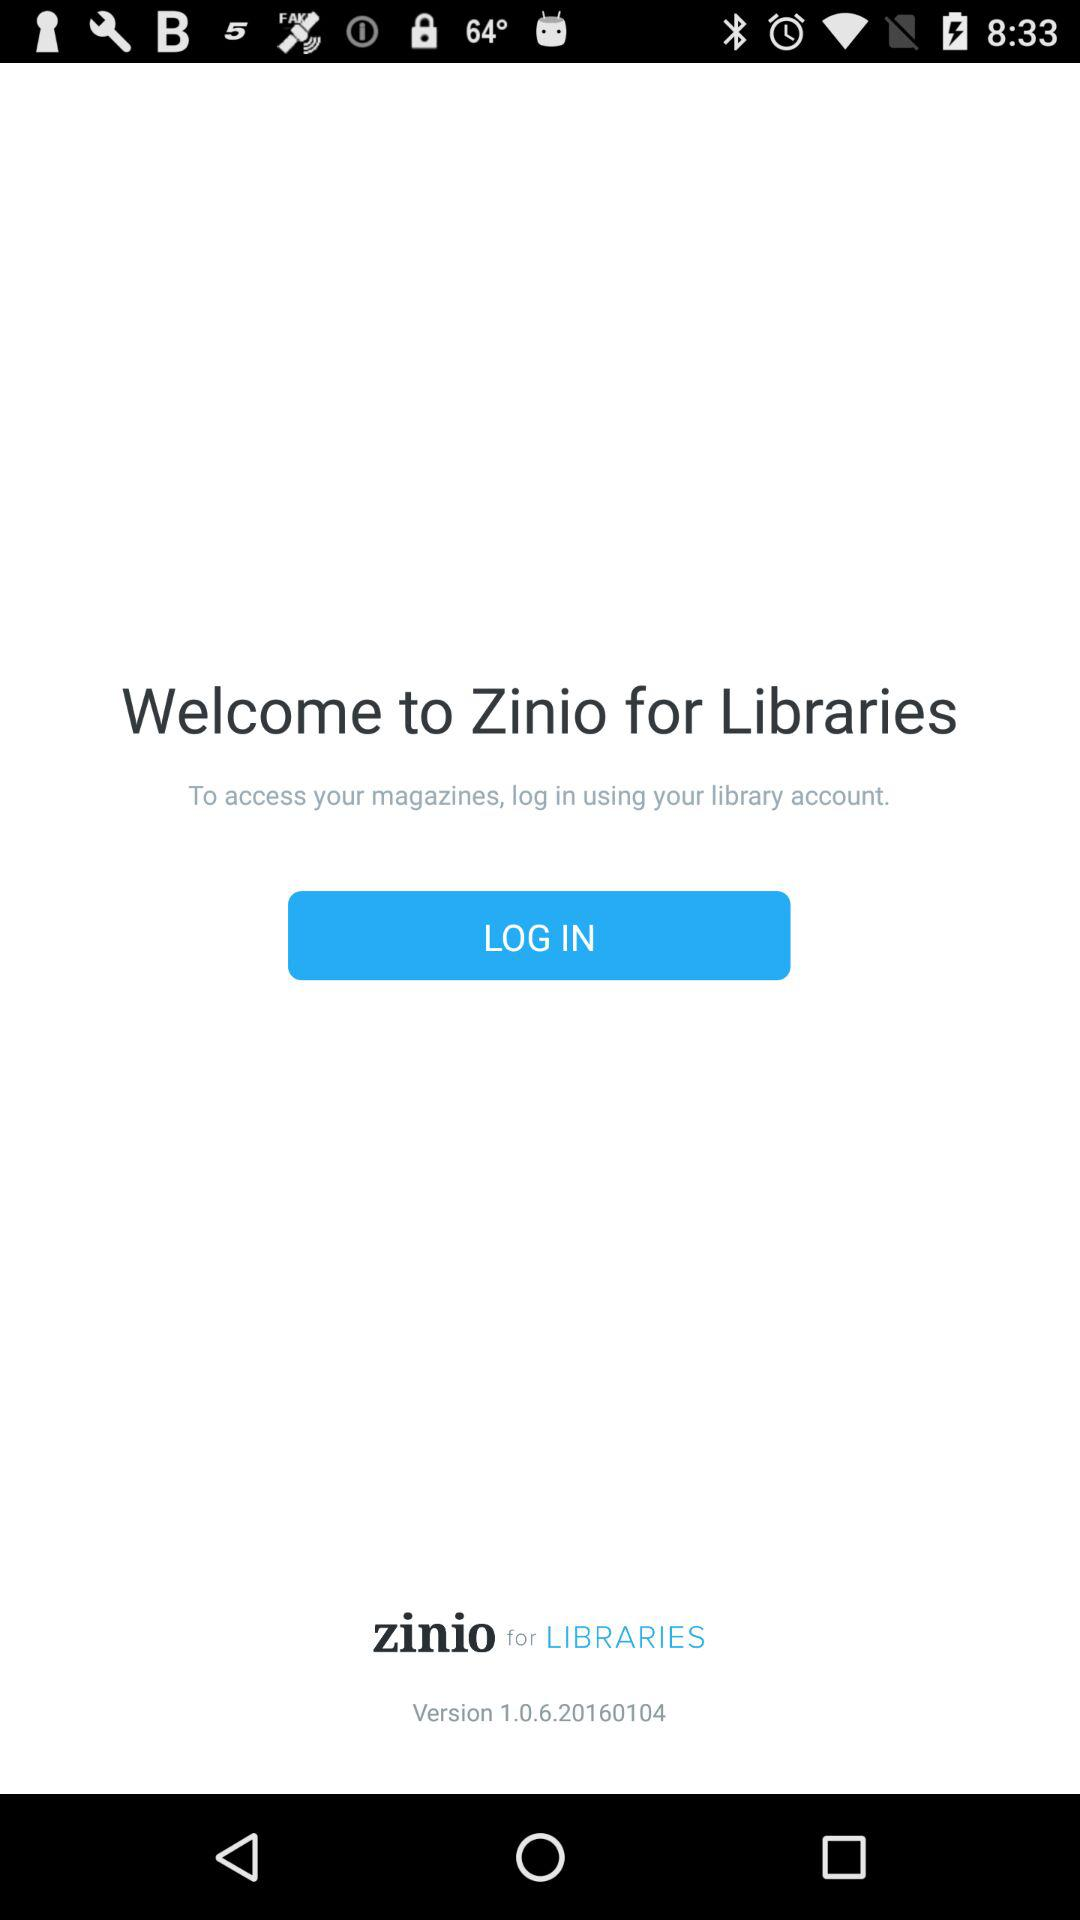What is the name of the application? The application name is "Zinio". 